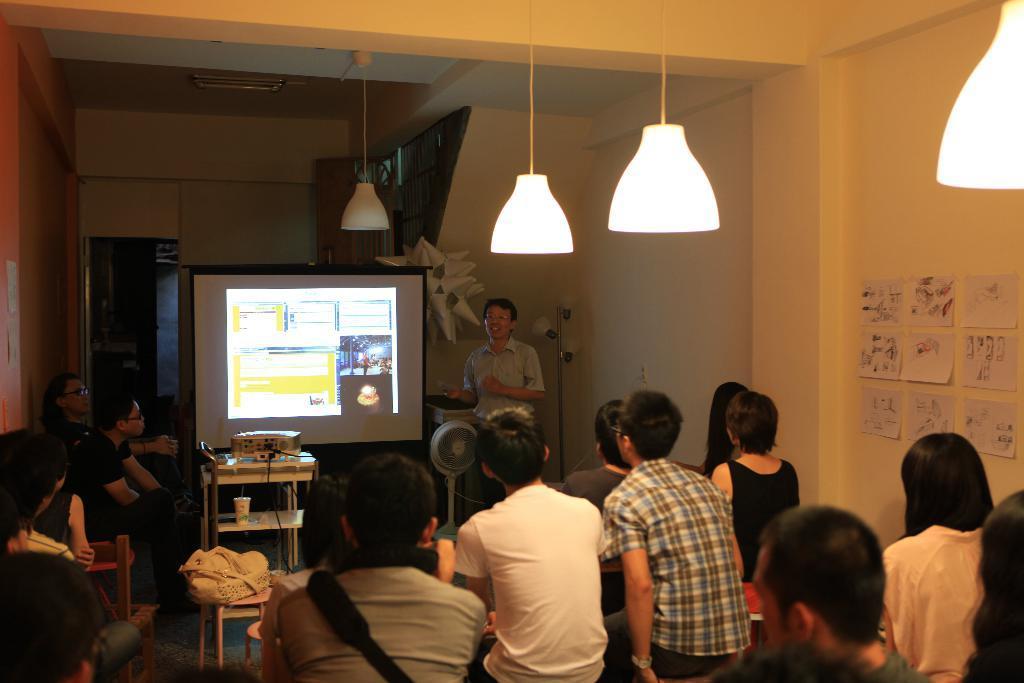In one or two sentences, can you explain what this image depicts? In this image, we can see people sitting and some of them are wearing bags. In the background, there is a person standing and we can see a screen and there are some objects on the stand, fans and poles. At the top, there are lights and we can see some papers on the wall and a door and there is roof. 